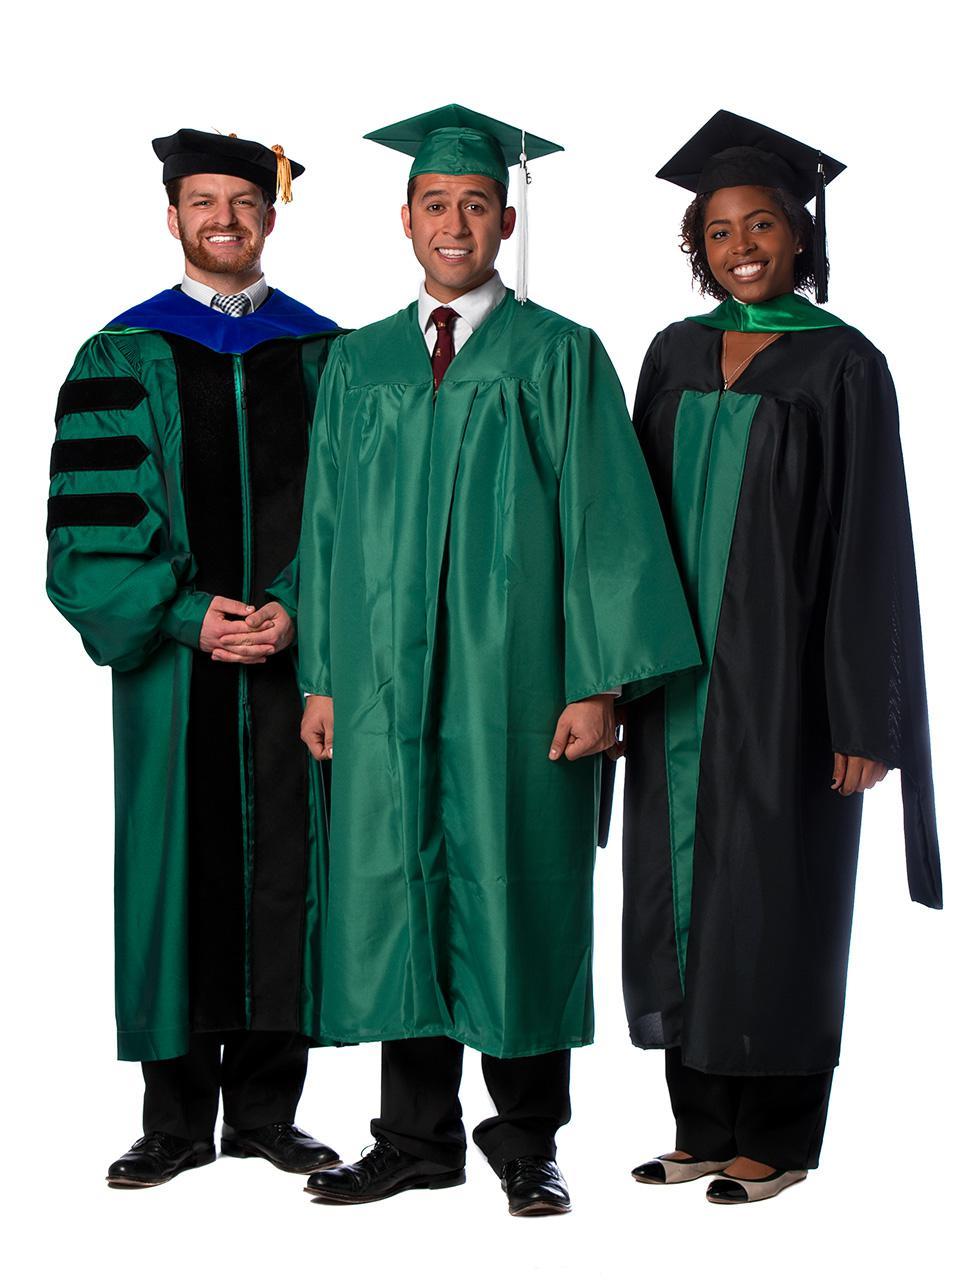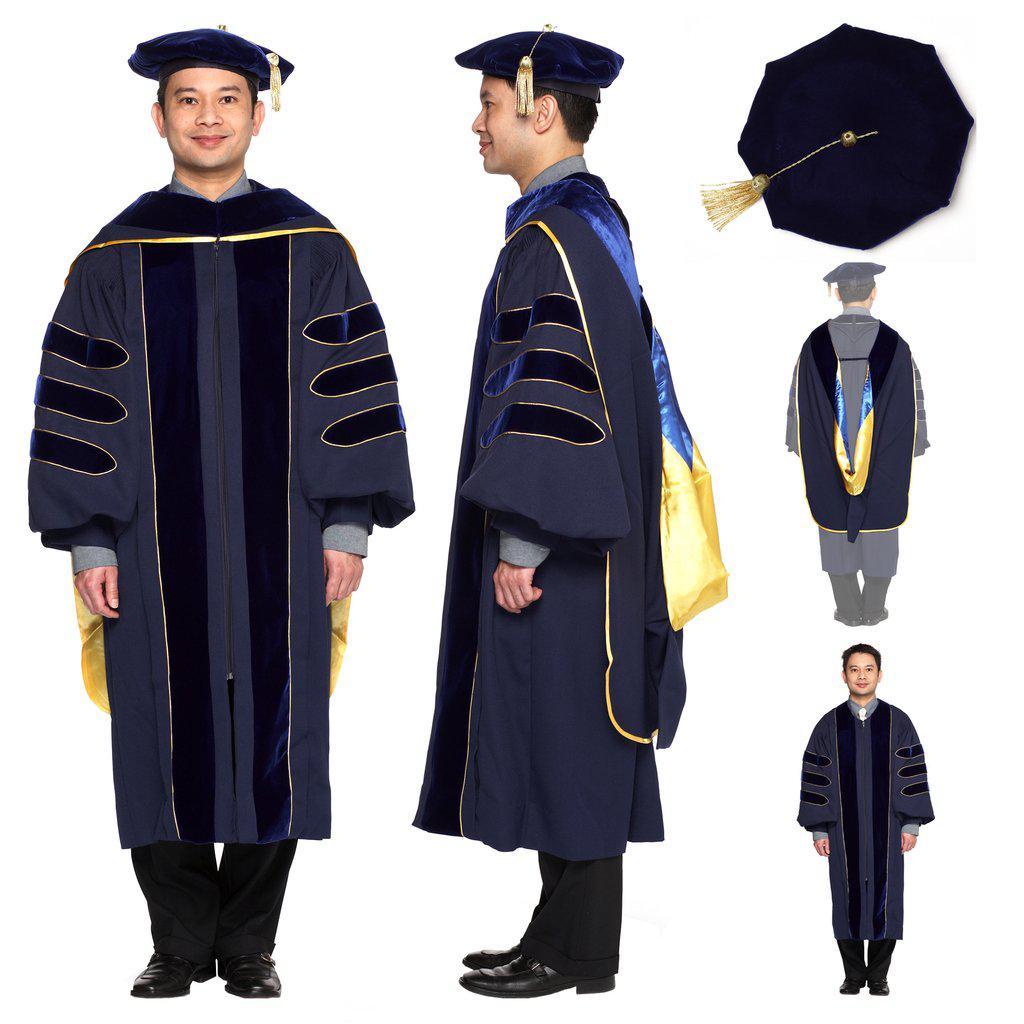The first image is the image on the left, the second image is the image on the right. Analyze the images presented: Is the assertion "The full lengths of all graduation gowns are shown." valid? Answer yes or no. Yes. 